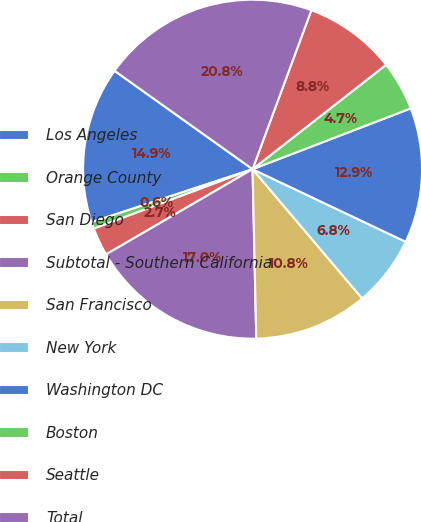<chart> <loc_0><loc_0><loc_500><loc_500><pie_chart><fcel>Los Angeles<fcel>Orange County<fcel>San Diego<fcel>Subtotal - Southern California<fcel>San Francisco<fcel>New York<fcel>Washington DC<fcel>Boston<fcel>Seattle<fcel>Total<nl><fcel>14.92%<fcel>0.64%<fcel>2.68%<fcel>16.96%<fcel>10.84%<fcel>6.76%<fcel>12.88%<fcel>4.72%<fcel>8.8%<fcel>20.78%<nl></chart> 